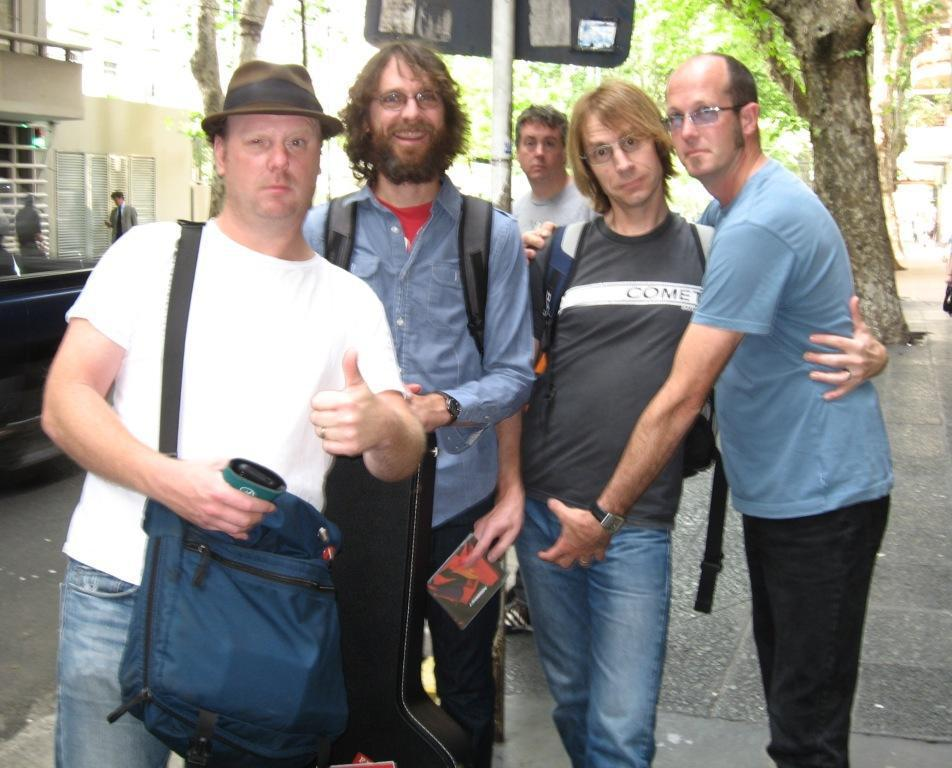What can be seen in the foreground of the image? There are men standing on the road. What is visible in the background of the image? There are sign boards and trees in the background of the image. What type of chairs can be seen in the image? There are no chairs present in the image. How does the income of the men affect the image? The income of the men is not mentioned or depicted in the image, so it cannot be determined how it might affect the image. 